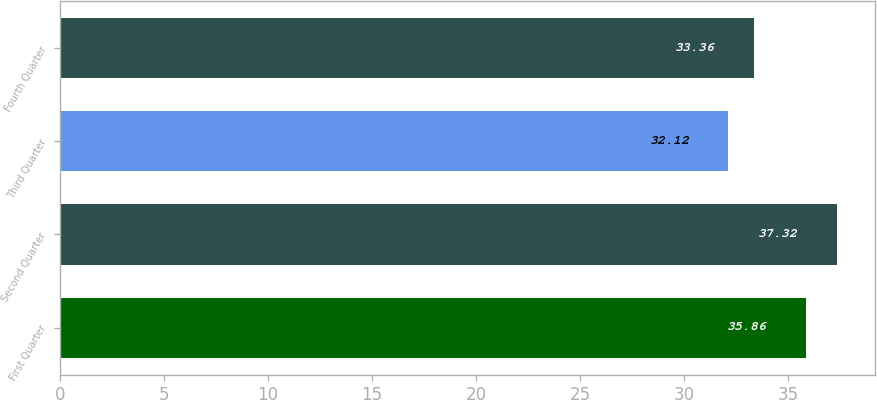Convert chart to OTSL. <chart><loc_0><loc_0><loc_500><loc_500><bar_chart><fcel>First Quarter<fcel>Second Quarter<fcel>Third Quarter<fcel>Fourth Quarter<nl><fcel>35.86<fcel>37.32<fcel>32.12<fcel>33.36<nl></chart> 